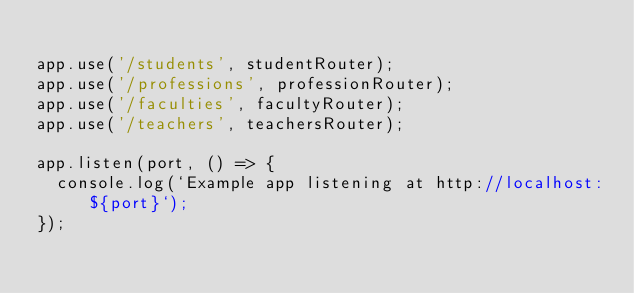Convert code to text. <code><loc_0><loc_0><loc_500><loc_500><_JavaScript_>
app.use('/students', studentRouter);
app.use('/professions', professionRouter);
app.use('/faculties', facultyRouter);
app.use('/teachers', teachersRouter);

app.listen(port, () => {
  console.log(`Example app listening at http://localhost:${port}`);
});
</code> 